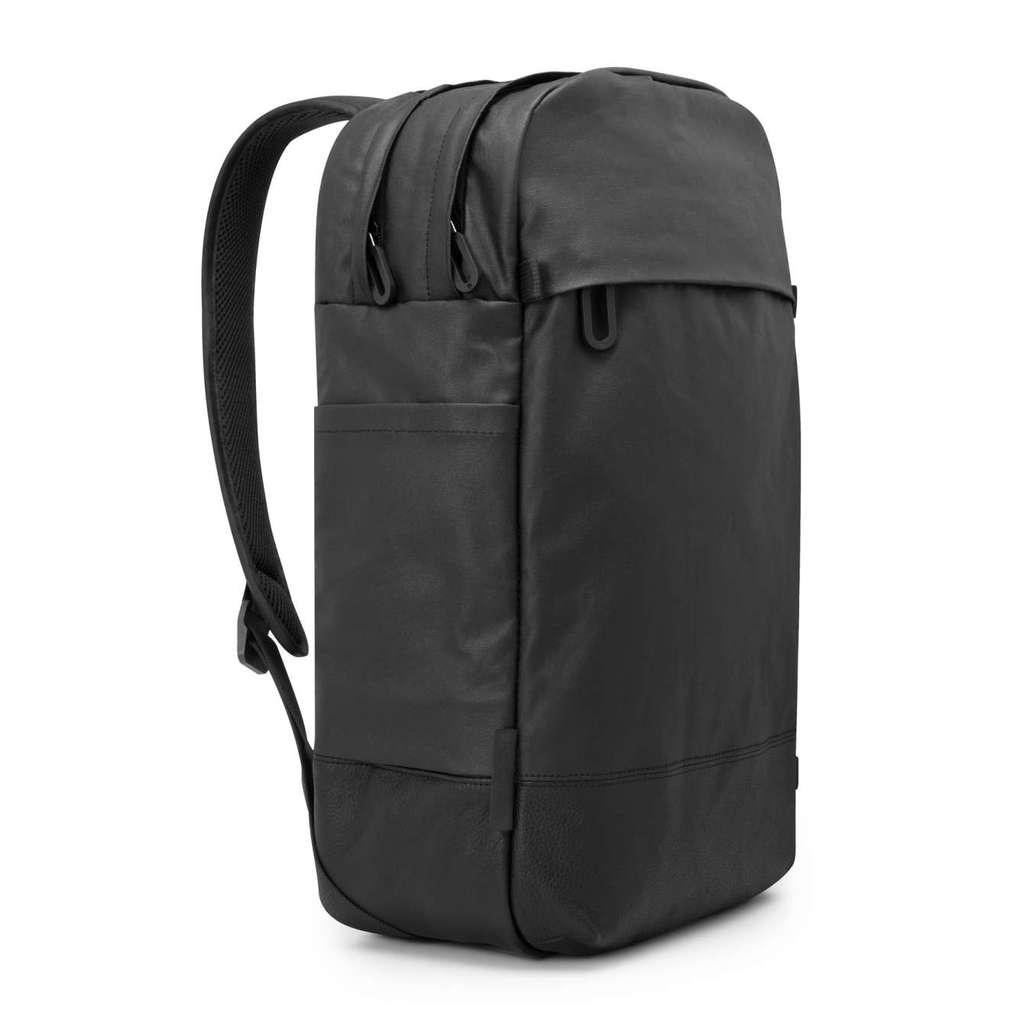What object can be seen in the image? There is a backpack in the image. Where is the backpack located? The backpack is placed on a surface. What color is the background of the image? The background of the image is white in color. How many crates are visible in the image? There are no crates present in the image. What route does the kite take in the image? There is no kite present in the image. 